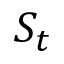<formula> <loc_0><loc_0><loc_500><loc_500>S _ { t }</formula> 